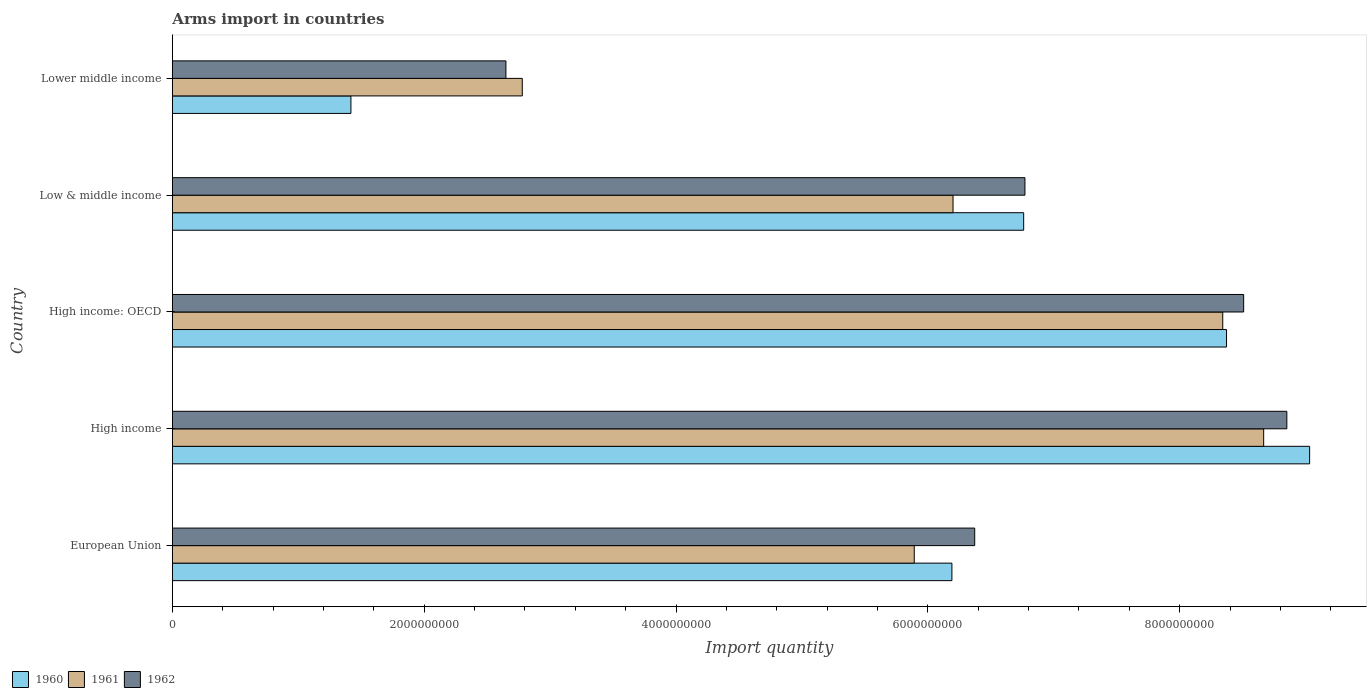How many different coloured bars are there?
Ensure brevity in your answer.  3. How many groups of bars are there?
Keep it short and to the point. 5. Are the number of bars per tick equal to the number of legend labels?
Provide a succinct answer. Yes. Are the number of bars on each tick of the Y-axis equal?
Make the answer very short. Yes. What is the label of the 5th group of bars from the top?
Provide a succinct answer. European Union. In how many cases, is the number of bars for a given country not equal to the number of legend labels?
Offer a very short reply. 0. What is the total arms import in 1961 in European Union?
Your response must be concise. 5.89e+09. Across all countries, what is the maximum total arms import in 1960?
Your response must be concise. 9.03e+09. Across all countries, what is the minimum total arms import in 1961?
Offer a very short reply. 2.78e+09. In which country was the total arms import in 1962 minimum?
Provide a short and direct response. Lower middle income. What is the total total arms import in 1962 in the graph?
Your response must be concise. 3.32e+1. What is the difference between the total arms import in 1961 in High income and that in Low & middle income?
Offer a terse response. 2.47e+09. What is the difference between the total arms import in 1961 in Lower middle income and the total arms import in 1960 in European Union?
Your response must be concise. -3.41e+09. What is the average total arms import in 1962 per country?
Offer a very short reply. 6.63e+09. What is the difference between the total arms import in 1962 and total arms import in 1960 in High income?
Provide a succinct answer. -1.81e+08. In how many countries, is the total arms import in 1962 greater than 1200000000 ?
Your answer should be very brief. 5. What is the ratio of the total arms import in 1961 in High income to that in Low & middle income?
Make the answer very short. 1.4. Is the total arms import in 1960 in European Union less than that in High income: OECD?
Provide a short and direct response. Yes. What is the difference between the highest and the second highest total arms import in 1961?
Offer a very short reply. 3.25e+08. What is the difference between the highest and the lowest total arms import in 1961?
Offer a very short reply. 5.89e+09. In how many countries, is the total arms import in 1962 greater than the average total arms import in 1962 taken over all countries?
Your answer should be compact. 3. How many countries are there in the graph?
Provide a succinct answer. 5. What is the difference between two consecutive major ticks on the X-axis?
Your answer should be compact. 2.00e+09. Are the values on the major ticks of X-axis written in scientific E-notation?
Your response must be concise. No. Does the graph contain any zero values?
Your answer should be compact. No. Does the graph contain grids?
Give a very brief answer. No. Where does the legend appear in the graph?
Your answer should be compact. Bottom left. How many legend labels are there?
Your response must be concise. 3. What is the title of the graph?
Your answer should be very brief. Arms import in countries. What is the label or title of the X-axis?
Your answer should be compact. Import quantity. What is the label or title of the Y-axis?
Keep it short and to the point. Country. What is the Import quantity of 1960 in European Union?
Provide a short and direct response. 6.19e+09. What is the Import quantity of 1961 in European Union?
Offer a terse response. 5.89e+09. What is the Import quantity in 1962 in European Union?
Your response must be concise. 6.37e+09. What is the Import quantity of 1960 in High income?
Make the answer very short. 9.03e+09. What is the Import quantity in 1961 in High income?
Your response must be concise. 8.67e+09. What is the Import quantity in 1962 in High income?
Offer a terse response. 8.85e+09. What is the Import quantity of 1960 in High income: OECD?
Make the answer very short. 8.37e+09. What is the Import quantity in 1961 in High income: OECD?
Provide a short and direct response. 8.34e+09. What is the Import quantity in 1962 in High income: OECD?
Ensure brevity in your answer.  8.51e+09. What is the Import quantity in 1960 in Low & middle income?
Provide a succinct answer. 6.76e+09. What is the Import quantity of 1961 in Low & middle income?
Ensure brevity in your answer.  6.20e+09. What is the Import quantity of 1962 in Low & middle income?
Provide a short and direct response. 6.77e+09. What is the Import quantity of 1960 in Lower middle income?
Offer a very short reply. 1.42e+09. What is the Import quantity in 1961 in Lower middle income?
Keep it short and to the point. 2.78e+09. What is the Import quantity of 1962 in Lower middle income?
Your answer should be compact. 2.65e+09. Across all countries, what is the maximum Import quantity in 1960?
Keep it short and to the point. 9.03e+09. Across all countries, what is the maximum Import quantity of 1961?
Provide a succinct answer. 8.67e+09. Across all countries, what is the maximum Import quantity in 1962?
Provide a short and direct response. 8.85e+09. Across all countries, what is the minimum Import quantity in 1960?
Make the answer very short. 1.42e+09. Across all countries, what is the minimum Import quantity of 1961?
Give a very brief answer. 2.78e+09. Across all countries, what is the minimum Import quantity in 1962?
Give a very brief answer. 2.65e+09. What is the total Import quantity in 1960 in the graph?
Give a very brief answer. 3.18e+1. What is the total Import quantity in 1961 in the graph?
Your answer should be compact. 3.19e+1. What is the total Import quantity in 1962 in the graph?
Your answer should be very brief. 3.32e+1. What is the difference between the Import quantity of 1960 in European Union and that in High income?
Provide a short and direct response. -2.84e+09. What is the difference between the Import quantity in 1961 in European Union and that in High income?
Offer a very short reply. -2.78e+09. What is the difference between the Import quantity in 1962 in European Union and that in High income?
Offer a very short reply. -2.48e+09. What is the difference between the Import quantity in 1960 in European Union and that in High income: OECD?
Offer a very short reply. -2.18e+09. What is the difference between the Import quantity of 1961 in European Union and that in High income: OECD?
Your response must be concise. -2.45e+09. What is the difference between the Import quantity of 1962 in European Union and that in High income: OECD?
Provide a succinct answer. -2.14e+09. What is the difference between the Import quantity in 1960 in European Union and that in Low & middle income?
Offer a terse response. -5.70e+08. What is the difference between the Import quantity of 1961 in European Union and that in Low & middle income?
Your answer should be compact. -3.08e+08. What is the difference between the Import quantity in 1962 in European Union and that in Low & middle income?
Give a very brief answer. -3.99e+08. What is the difference between the Import quantity of 1960 in European Union and that in Lower middle income?
Ensure brevity in your answer.  4.77e+09. What is the difference between the Import quantity in 1961 in European Union and that in Lower middle income?
Make the answer very short. 3.11e+09. What is the difference between the Import quantity of 1962 in European Union and that in Lower middle income?
Keep it short and to the point. 3.72e+09. What is the difference between the Import quantity in 1960 in High income and that in High income: OECD?
Provide a succinct answer. 6.60e+08. What is the difference between the Import quantity in 1961 in High income and that in High income: OECD?
Keep it short and to the point. 3.25e+08. What is the difference between the Import quantity in 1962 in High income and that in High income: OECD?
Offer a terse response. 3.43e+08. What is the difference between the Import quantity of 1960 in High income and that in Low & middle income?
Provide a succinct answer. 2.27e+09. What is the difference between the Import quantity of 1961 in High income and that in Low & middle income?
Your answer should be compact. 2.47e+09. What is the difference between the Import quantity in 1962 in High income and that in Low & middle income?
Provide a short and direct response. 2.08e+09. What is the difference between the Import quantity in 1960 in High income and that in Lower middle income?
Make the answer very short. 7.61e+09. What is the difference between the Import quantity in 1961 in High income and that in Lower middle income?
Your answer should be compact. 5.89e+09. What is the difference between the Import quantity of 1962 in High income and that in Lower middle income?
Offer a terse response. 6.20e+09. What is the difference between the Import quantity of 1960 in High income: OECD and that in Low & middle income?
Provide a short and direct response. 1.61e+09. What is the difference between the Import quantity in 1961 in High income: OECD and that in Low & middle income?
Make the answer very short. 2.14e+09. What is the difference between the Import quantity of 1962 in High income: OECD and that in Low & middle income?
Provide a succinct answer. 1.74e+09. What is the difference between the Import quantity of 1960 in High income: OECD and that in Lower middle income?
Keep it short and to the point. 6.95e+09. What is the difference between the Import quantity of 1961 in High income: OECD and that in Lower middle income?
Give a very brief answer. 5.56e+09. What is the difference between the Import quantity in 1962 in High income: OECD and that in Lower middle income?
Give a very brief answer. 5.86e+09. What is the difference between the Import quantity in 1960 in Low & middle income and that in Lower middle income?
Offer a terse response. 5.34e+09. What is the difference between the Import quantity of 1961 in Low & middle income and that in Lower middle income?
Give a very brief answer. 3.42e+09. What is the difference between the Import quantity of 1962 in Low & middle income and that in Lower middle income?
Your response must be concise. 4.12e+09. What is the difference between the Import quantity of 1960 in European Union and the Import quantity of 1961 in High income?
Provide a succinct answer. -2.48e+09. What is the difference between the Import quantity of 1960 in European Union and the Import quantity of 1962 in High income?
Your answer should be compact. -2.66e+09. What is the difference between the Import quantity in 1961 in European Union and the Import quantity in 1962 in High income?
Keep it short and to the point. -2.96e+09. What is the difference between the Import quantity in 1960 in European Union and the Import quantity in 1961 in High income: OECD?
Give a very brief answer. -2.15e+09. What is the difference between the Import quantity of 1960 in European Union and the Import quantity of 1962 in High income: OECD?
Give a very brief answer. -2.32e+09. What is the difference between the Import quantity in 1961 in European Union and the Import quantity in 1962 in High income: OECD?
Offer a very short reply. -2.62e+09. What is the difference between the Import quantity in 1960 in European Union and the Import quantity in 1961 in Low & middle income?
Your answer should be compact. -9.00e+06. What is the difference between the Import quantity in 1960 in European Union and the Import quantity in 1962 in Low & middle income?
Your answer should be very brief. -5.80e+08. What is the difference between the Import quantity of 1961 in European Union and the Import quantity of 1962 in Low & middle income?
Provide a short and direct response. -8.79e+08. What is the difference between the Import quantity of 1960 in European Union and the Import quantity of 1961 in Lower middle income?
Provide a short and direct response. 3.41e+09. What is the difference between the Import quantity in 1960 in European Union and the Import quantity in 1962 in Lower middle income?
Your answer should be very brief. 3.54e+09. What is the difference between the Import quantity of 1961 in European Union and the Import quantity of 1962 in Lower middle income?
Ensure brevity in your answer.  3.24e+09. What is the difference between the Import quantity in 1960 in High income and the Import quantity in 1961 in High income: OECD?
Your response must be concise. 6.90e+08. What is the difference between the Import quantity in 1960 in High income and the Import quantity in 1962 in High income: OECD?
Offer a very short reply. 5.24e+08. What is the difference between the Import quantity of 1961 in High income and the Import quantity of 1962 in High income: OECD?
Your answer should be compact. 1.59e+08. What is the difference between the Import quantity in 1960 in High income and the Import quantity in 1961 in Low & middle income?
Offer a terse response. 2.83e+09. What is the difference between the Import quantity in 1960 in High income and the Import quantity in 1962 in Low & middle income?
Your answer should be compact. 2.26e+09. What is the difference between the Import quantity of 1961 in High income and the Import quantity of 1962 in Low & middle income?
Your response must be concise. 1.90e+09. What is the difference between the Import quantity in 1960 in High income and the Import quantity in 1961 in Lower middle income?
Ensure brevity in your answer.  6.25e+09. What is the difference between the Import quantity of 1960 in High income and the Import quantity of 1962 in Lower middle income?
Ensure brevity in your answer.  6.38e+09. What is the difference between the Import quantity in 1961 in High income and the Import quantity in 1962 in Lower middle income?
Give a very brief answer. 6.02e+09. What is the difference between the Import quantity of 1960 in High income: OECD and the Import quantity of 1961 in Low & middle income?
Your answer should be very brief. 2.17e+09. What is the difference between the Import quantity in 1960 in High income: OECD and the Import quantity in 1962 in Low & middle income?
Keep it short and to the point. 1.60e+09. What is the difference between the Import quantity of 1961 in High income: OECD and the Import quantity of 1962 in Low & middle income?
Your answer should be compact. 1.57e+09. What is the difference between the Import quantity in 1960 in High income: OECD and the Import quantity in 1961 in Lower middle income?
Offer a very short reply. 5.59e+09. What is the difference between the Import quantity in 1960 in High income: OECD and the Import quantity in 1962 in Lower middle income?
Provide a succinct answer. 5.72e+09. What is the difference between the Import quantity of 1961 in High income: OECD and the Import quantity of 1962 in Lower middle income?
Keep it short and to the point. 5.69e+09. What is the difference between the Import quantity of 1960 in Low & middle income and the Import quantity of 1961 in Lower middle income?
Ensure brevity in your answer.  3.98e+09. What is the difference between the Import quantity of 1960 in Low & middle income and the Import quantity of 1962 in Lower middle income?
Provide a succinct answer. 4.11e+09. What is the difference between the Import quantity of 1961 in Low & middle income and the Import quantity of 1962 in Lower middle income?
Your response must be concise. 3.55e+09. What is the average Import quantity in 1960 per country?
Your response must be concise. 6.35e+09. What is the average Import quantity in 1961 per country?
Provide a succinct answer. 6.38e+09. What is the average Import quantity in 1962 per country?
Provide a short and direct response. 6.63e+09. What is the difference between the Import quantity in 1960 and Import quantity in 1961 in European Union?
Offer a terse response. 2.99e+08. What is the difference between the Import quantity in 1960 and Import quantity in 1962 in European Union?
Ensure brevity in your answer.  -1.81e+08. What is the difference between the Import quantity in 1961 and Import quantity in 1962 in European Union?
Ensure brevity in your answer.  -4.80e+08. What is the difference between the Import quantity of 1960 and Import quantity of 1961 in High income?
Offer a very short reply. 3.65e+08. What is the difference between the Import quantity in 1960 and Import quantity in 1962 in High income?
Provide a succinct answer. 1.81e+08. What is the difference between the Import quantity of 1961 and Import quantity of 1962 in High income?
Give a very brief answer. -1.84e+08. What is the difference between the Import quantity of 1960 and Import quantity of 1961 in High income: OECD?
Provide a short and direct response. 3.00e+07. What is the difference between the Import quantity of 1960 and Import quantity of 1962 in High income: OECD?
Provide a short and direct response. -1.36e+08. What is the difference between the Import quantity in 1961 and Import quantity in 1962 in High income: OECD?
Keep it short and to the point. -1.66e+08. What is the difference between the Import quantity in 1960 and Import quantity in 1961 in Low & middle income?
Provide a succinct answer. 5.61e+08. What is the difference between the Import quantity of 1960 and Import quantity of 1962 in Low & middle income?
Your answer should be very brief. -1.00e+07. What is the difference between the Import quantity of 1961 and Import quantity of 1962 in Low & middle income?
Your answer should be very brief. -5.71e+08. What is the difference between the Import quantity in 1960 and Import quantity in 1961 in Lower middle income?
Provide a short and direct response. -1.36e+09. What is the difference between the Import quantity of 1960 and Import quantity of 1962 in Lower middle income?
Keep it short and to the point. -1.23e+09. What is the difference between the Import quantity of 1961 and Import quantity of 1962 in Lower middle income?
Offer a very short reply. 1.30e+08. What is the ratio of the Import quantity of 1960 in European Union to that in High income?
Your answer should be very brief. 0.69. What is the ratio of the Import quantity of 1961 in European Union to that in High income?
Provide a short and direct response. 0.68. What is the ratio of the Import quantity of 1962 in European Union to that in High income?
Make the answer very short. 0.72. What is the ratio of the Import quantity of 1960 in European Union to that in High income: OECD?
Make the answer very short. 0.74. What is the ratio of the Import quantity in 1961 in European Union to that in High income: OECD?
Your answer should be compact. 0.71. What is the ratio of the Import quantity in 1962 in European Union to that in High income: OECD?
Your answer should be compact. 0.75. What is the ratio of the Import quantity of 1960 in European Union to that in Low & middle income?
Provide a succinct answer. 0.92. What is the ratio of the Import quantity of 1961 in European Union to that in Low & middle income?
Ensure brevity in your answer.  0.95. What is the ratio of the Import quantity of 1962 in European Union to that in Low & middle income?
Provide a short and direct response. 0.94. What is the ratio of the Import quantity in 1960 in European Union to that in Lower middle income?
Your answer should be compact. 4.37. What is the ratio of the Import quantity of 1961 in European Union to that in Lower middle income?
Keep it short and to the point. 2.12. What is the ratio of the Import quantity in 1962 in European Union to that in Lower middle income?
Give a very brief answer. 2.41. What is the ratio of the Import quantity in 1960 in High income to that in High income: OECD?
Keep it short and to the point. 1.08. What is the ratio of the Import quantity of 1961 in High income to that in High income: OECD?
Give a very brief answer. 1.04. What is the ratio of the Import quantity in 1962 in High income to that in High income: OECD?
Ensure brevity in your answer.  1.04. What is the ratio of the Import quantity of 1960 in High income to that in Low & middle income?
Offer a terse response. 1.34. What is the ratio of the Import quantity of 1961 in High income to that in Low & middle income?
Your response must be concise. 1.4. What is the ratio of the Import quantity of 1962 in High income to that in Low & middle income?
Keep it short and to the point. 1.31. What is the ratio of the Import quantity of 1960 in High income to that in Lower middle income?
Offer a terse response. 6.37. What is the ratio of the Import quantity of 1961 in High income to that in Lower middle income?
Keep it short and to the point. 3.12. What is the ratio of the Import quantity in 1962 in High income to that in Lower middle income?
Your answer should be very brief. 3.34. What is the ratio of the Import quantity in 1960 in High income: OECD to that in Low & middle income?
Give a very brief answer. 1.24. What is the ratio of the Import quantity in 1961 in High income: OECD to that in Low & middle income?
Offer a terse response. 1.35. What is the ratio of the Import quantity of 1962 in High income: OECD to that in Low & middle income?
Provide a short and direct response. 1.26. What is the ratio of the Import quantity in 1960 in High income: OECD to that in Lower middle income?
Ensure brevity in your answer.  5.9. What is the ratio of the Import quantity of 1961 in High income: OECD to that in Lower middle income?
Provide a succinct answer. 3. What is the ratio of the Import quantity in 1962 in High income: OECD to that in Lower middle income?
Provide a succinct answer. 3.21. What is the ratio of the Import quantity in 1960 in Low & middle income to that in Lower middle income?
Give a very brief answer. 4.77. What is the ratio of the Import quantity of 1961 in Low & middle income to that in Lower middle income?
Provide a succinct answer. 2.23. What is the ratio of the Import quantity of 1962 in Low & middle income to that in Lower middle income?
Provide a short and direct response. 2.56. What is the difference between the highest and the second highest Import quantity in 1960?
Offer a terse response. 6.60e+08. What is the difference between the highest and the second highest Import quantity in 1961?
Offer a very short reply. 3.25e+08. What is the difference between the highest and the second highest Import quantity in 1962?
Your response must be concise. 3.43e+08. What is the difference between the highest and the lowest Import quantity of 1960?
Make the answer very short. 7.61e+09. What is the difference between the highest and the lowest Import quantity in 1961?
Your response must be concise. 5.89e+09. What is the difference between the highest and the lowest Import quantity of 1962?
Your response must be concise. 6.20e+09. 